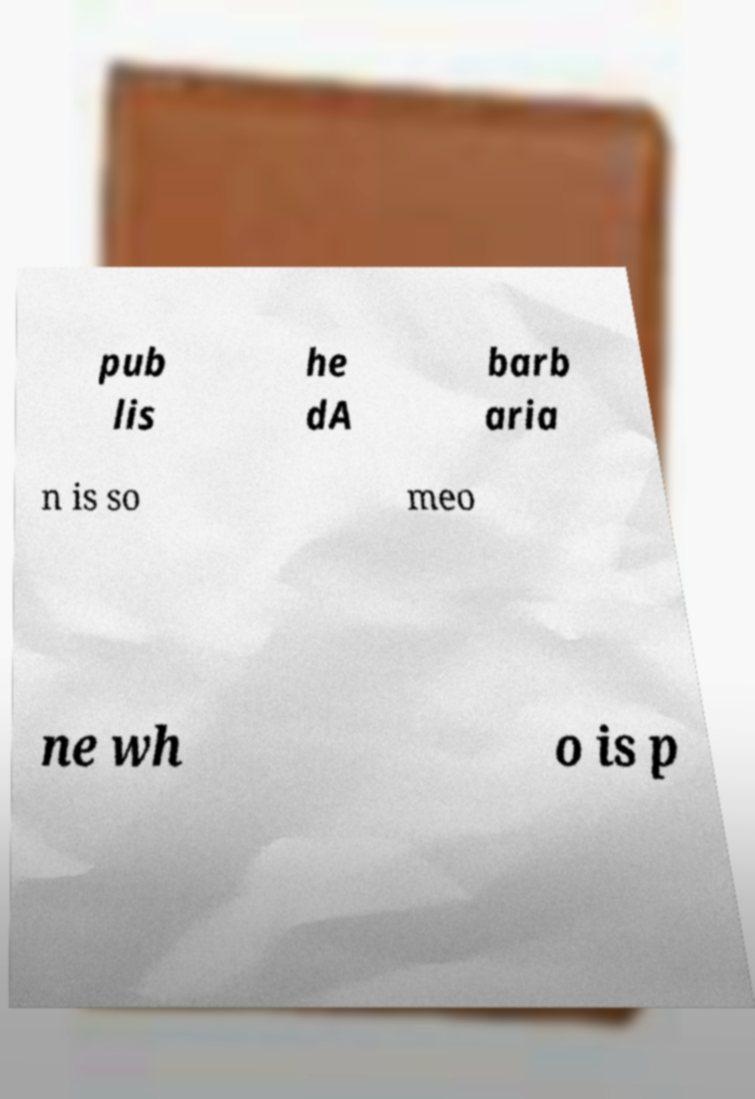There's text embedded in this image that I need extracted. Can you transcribe it verbatim? pub lis he dA barb aria n is so meo ne wh o is p 